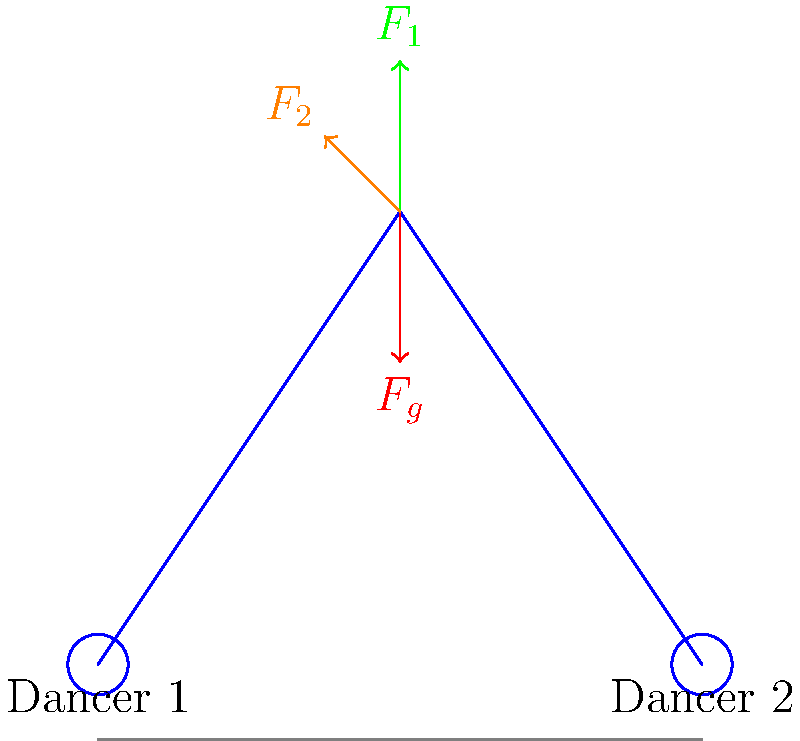In a partner lift during a dance performance, Dancer 1 lifts Dancer 2. The free-body diagram shows the forces acting on Dancer 2 at the moment of the lift. If Dancer 2 weighs 600 N and the lift is performed smoothly with constant velocity, calculate the magnitude of force $F_1$ exerted by Dancer 1 on Dancer 2. Assume that $F_2$ is at a 45-degree angle to the horizontal. To solve this problem, we'll follow these steps:

1) First, we need to recognize that since the lift is performed with constant velocity, the net force on Dancer 2 must be zero (Newton's First Law).

2) We can break this down into vertical and horizontal components:

   Vertical: $F_1 - F_g + F_2\sin(45°) = 0$
   Horizontal: $F_2\cos(45°) = 0$

3) We're given that $F_g = 600$ N (the weight of Dancer 2).

4) We know that $\sin(45°) = \cos(45°) = \frac{1}{\sqrt{2}} \approx 0.707$

5) From the vertical equation:
   $F_1 = F_g - F_2\sin(45°)$

6) We don't know $F_2$, but we can find it from the horizontal equation:
   $F_2\cos(45°) = 0$
   This is only true if $F_2 = 0$

7) Substituting back into the equation for $F_1$:
   $F_1 = F_g - 0 = 600$ N

Therefore, the upward force $F_1$ exerted by Dancer 1 on Dancer 2 is equal to Dancer 2's weight, 600 N.
Answer: 600 N 